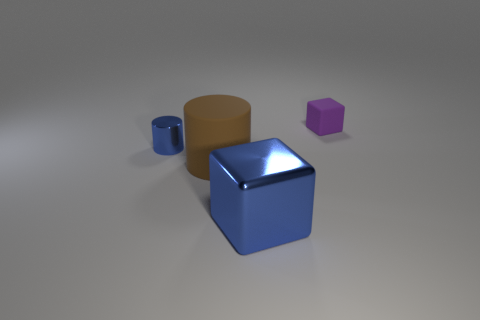Add 3 big shiny things. How many objects exist? 7 Subtract 0 brown cubes. How many objects are left? 4 Subtract 2 cylinders. How many cylinders are left? 0 Subtract all purple blocks. Subtract all cyan cylinders. How many blocks are left? 1 Subtract all green cubes. How many cyan cylinders are left? 0 Subtract all red metallic blocks. Subtract all small cylinders. How many objects are left? 3 Add 4 big brown things. How many big brown things are left? 5 Add 3 tiny green rubber balls. How many tiny green rubber balls exist? 3 Subtract all purple cubes. How many cubes are left? 1 